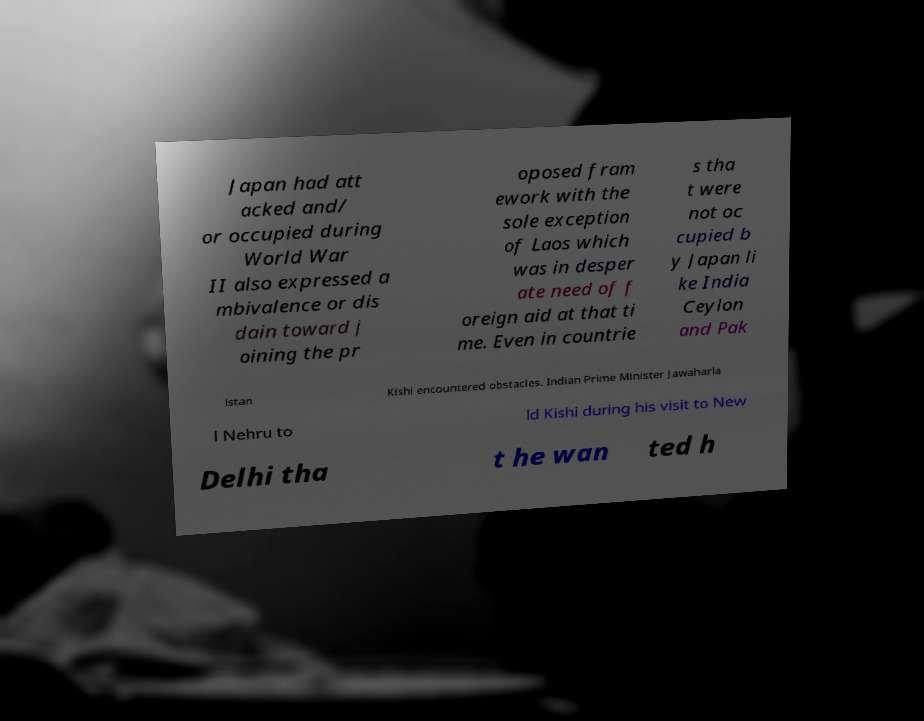Can you accurately transcribe the text from the provided image for me? Japan had att acked and/ or occupied during World War II also expressed a mbivalence or dis dain toward j oining the pr oposed fram ework with the sole exception of Laos which was in desper ate need of f oreign aid at that ti me. Even in countrie s tha t were not oc cupied b y Japan li ke India Ceylon and Pak istan Kishi encountered obstacles. Indian Prime Minister Jawaharla l Nehru to ld Kishi during his visit to New Delhi tha t he wan ted h 